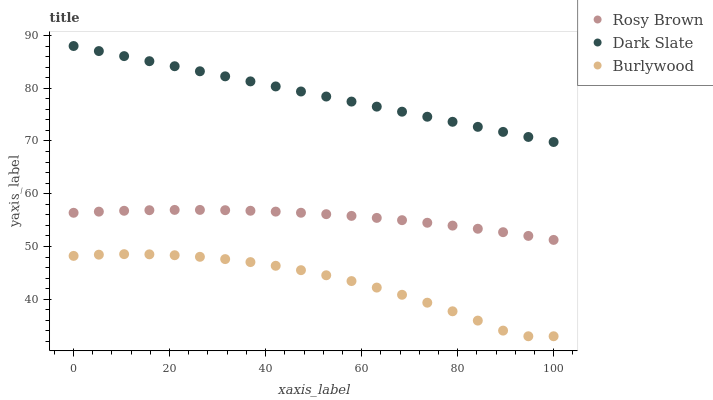Does Burlywood have the minimum area under the curve?
Answer yes or no. Yes. Does Dark Slate have the maximum area under the curve?
Answer yes or no. Yes. Does Rosy Brown have the minimum area under the curve?
Answer yes or no. No. Does Rosy Brown have the maximum area under the curve?
Answer yes or no. No. Is Dark Slate the smoothest?
Answer yes or no. Yes. Is Burlywood the roughest?
Answer yes or no. Yes. Is Rosy Brown the smoothest?
Answer yes or no. No. Is Rosy Brown the roughest?
Answer yes or no. No. Does Burlywood have the lowest value?
Answer yes or no. Yes. Does Rosy Brown have the lowest value?
Answer yes or no. No. Does Dark Slate have the highest value?
Answer yes or no. Yes. Does Rosy Brown have the highest value?
Answer yes or no. No. Is Burlywood less than Rosy Brown?
Answer yes or no. Yes. Is Rosy Brown greater than Burlywood?
Answer yes or no. Yes. Does Burlywood intersect Rosy Brown?
Answer yes or no. No. 